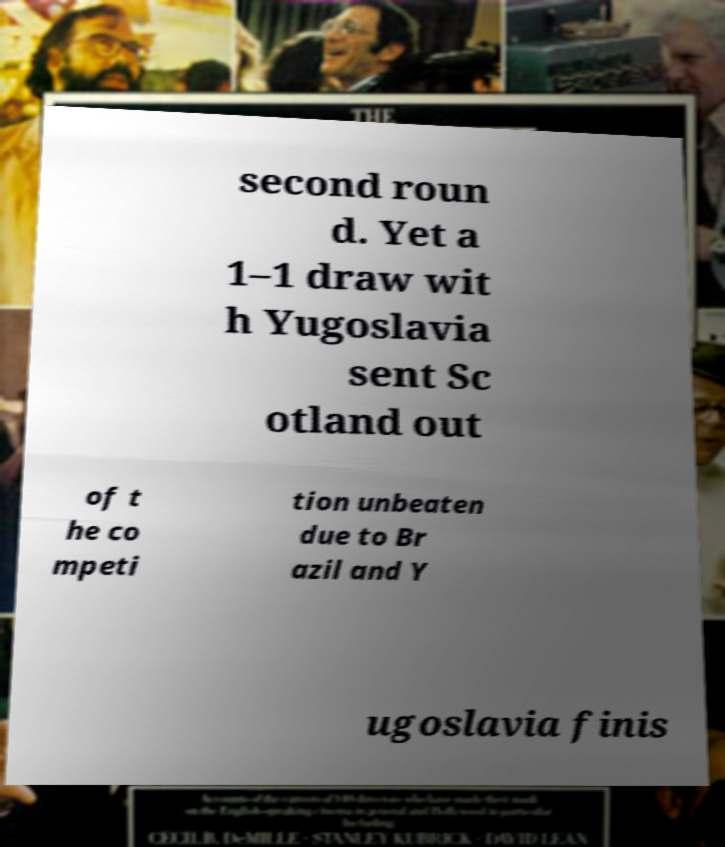Could you extract and type out the text from this image? second roun d. Yet a 1–1 draw wit h Yugoslavia sent Sc otland out of t he co mpeti tion unbeaten due to Br azil and Y ugoslavia finis 